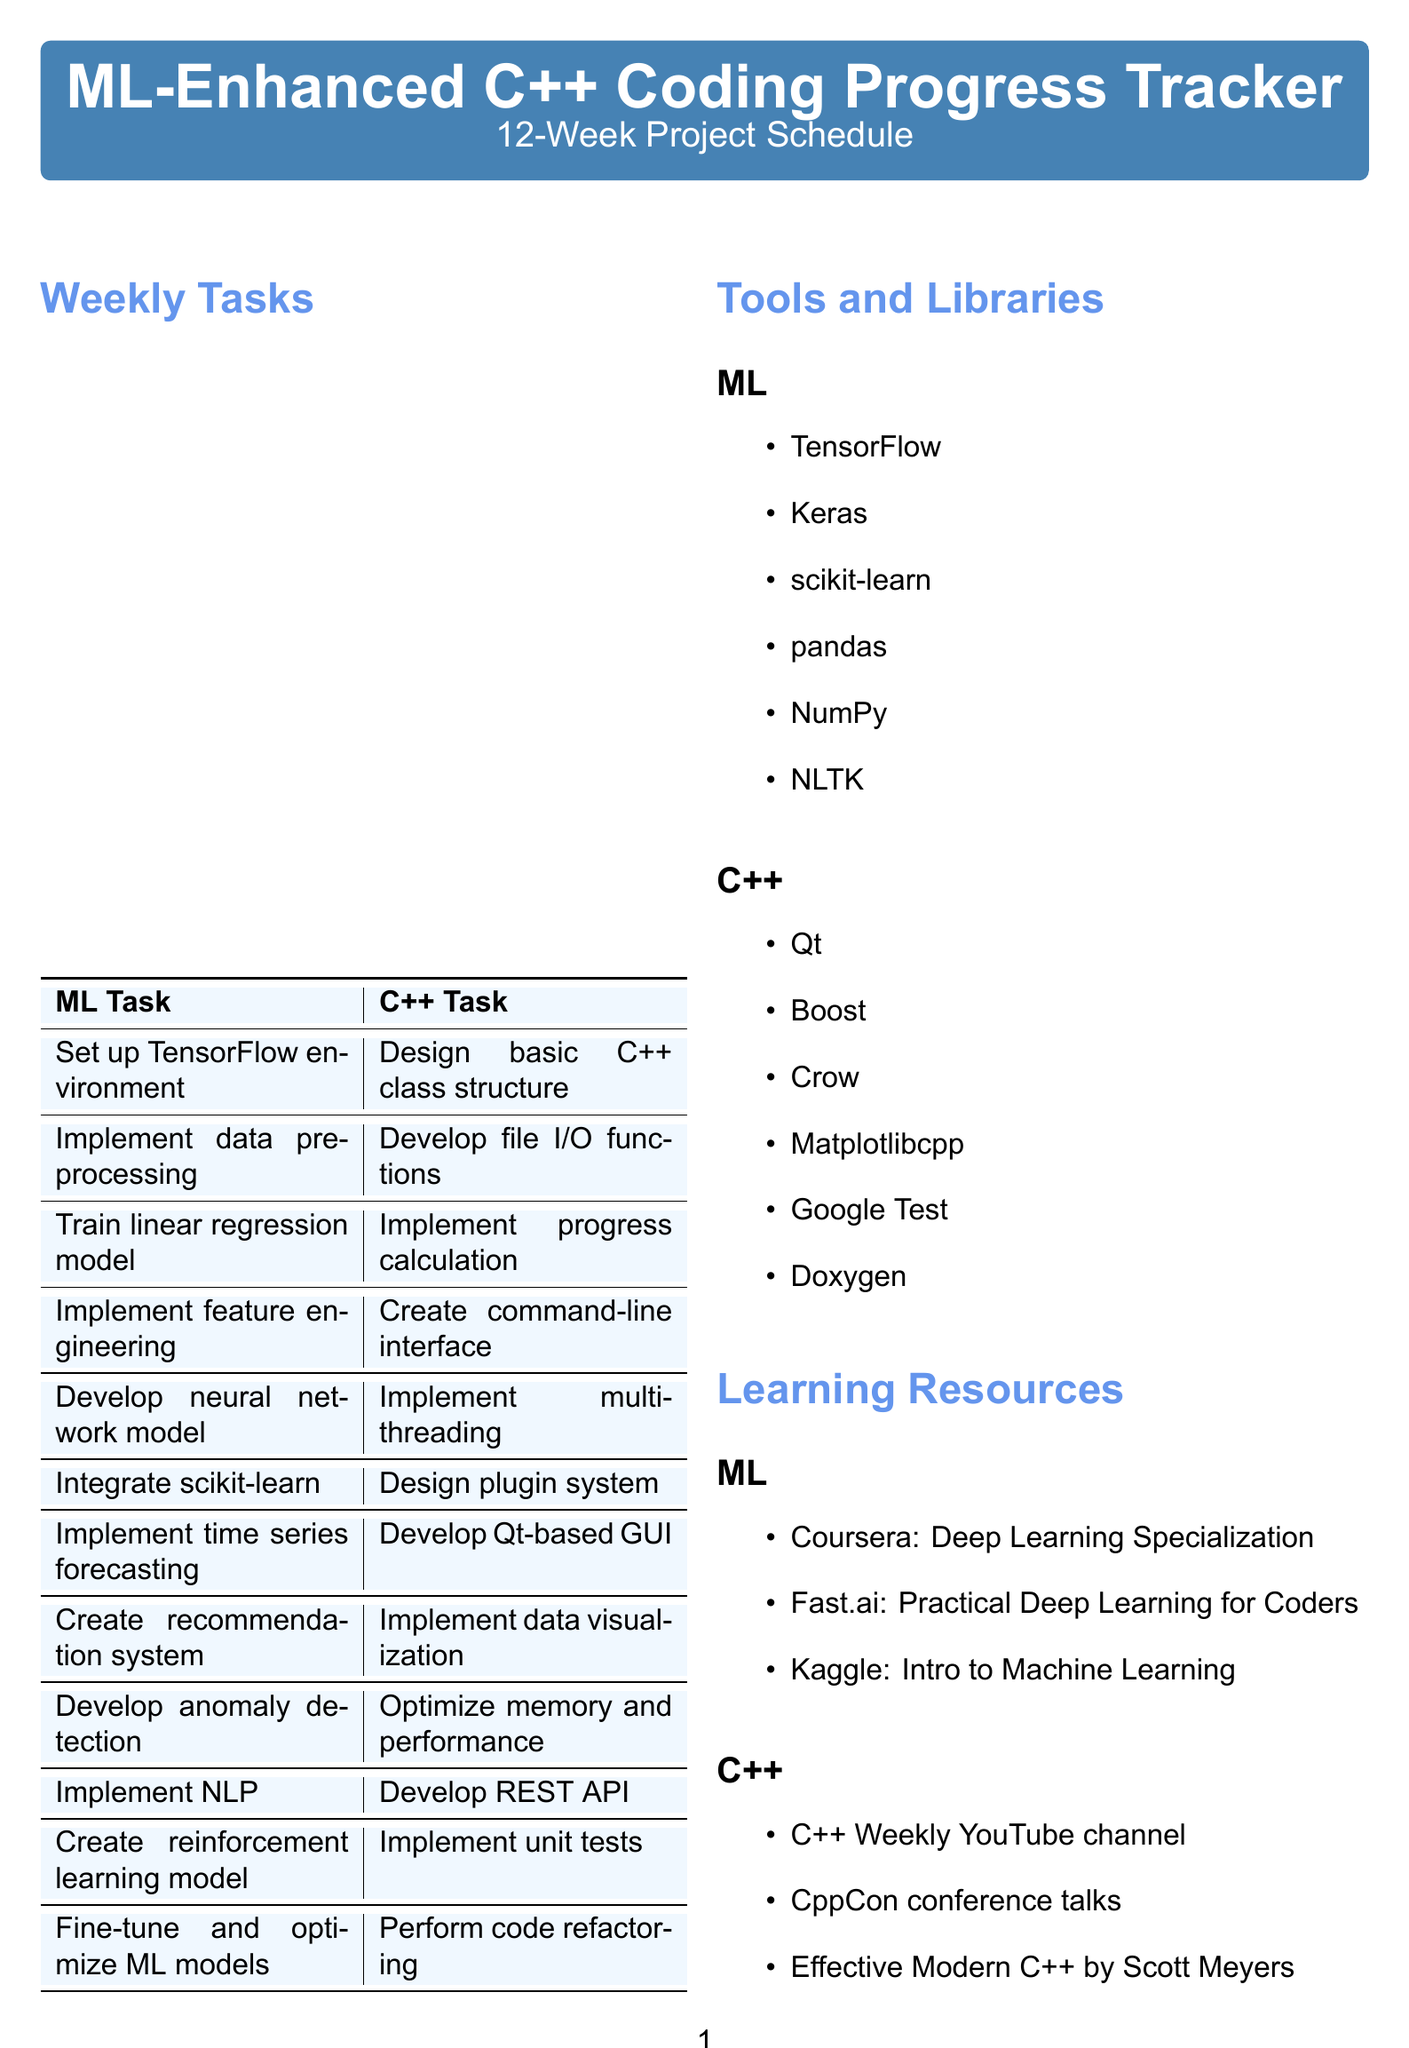What is the project duration? The project duration is stated in the document as "12 weeks."
Answer: 12 weeks Which library is used for data preprocessing? The document lists pandas as the library for data preprocessing in week 2.
Answer: pandas What task is associated with week 5? The tasks for week 5 are related to developing a neural network model and implementing multi-threading.
Answer: Develop a neural network model using Keras for task difficulty estimation What is the milestone for week 8? The document describes the milestone for week 8 as having a fully functional GUI with data visualization and task recommendations.
Answer: Fully functional GUI with data visualization and task recommendations How many ML tasks are outlined in the document? The document lists 12 weekly tasks under ML, indicating the total count.
Answer: 12 Which C++ library is mentioned for implementing tests? The document lists Google Test as the library for implementing tests in the C++ tasks.
Answer: Google Test What task involves creating a recommendation system? The recommendation system is listed under the ML tasks for week 8.
Answer: Create a recommendation system for suggesting similar tasks Which week is dedicated to fine-tuning ML models? The document specifies that week 12 is focused on fine-tuning the ML models for production use.
Answer: 12 What is the title of the project? The title of the project is explicitly stated in the document as "ML-Enhanced C++ Coding Progress Tracker."
Answer: ML-Enhanced C++ Coding Progress Tracker 